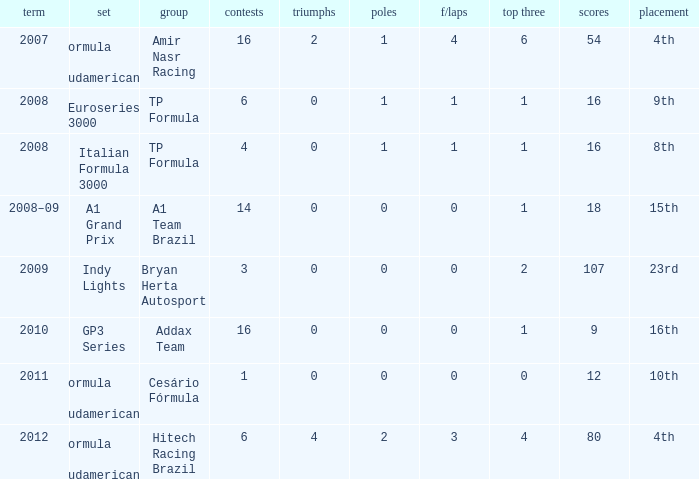How many points did he win in the race with more than 1.0 poles? 80.0. 